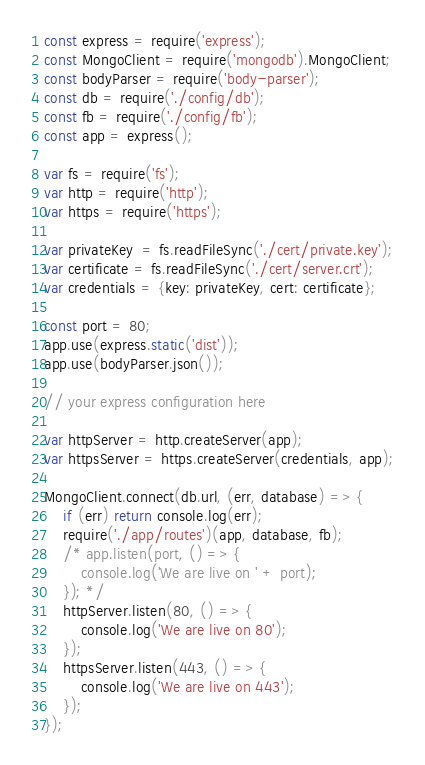Convert code to text. <code><loc_0><loc_0><loc_500><loc_500><_JavaScript_>const express = require('express');
const MongoClient = require('mongodb').MongoClient;
const bodyParser = require('body-parser');
const db = require('./config/db');
const fb = require('./config/fb');
const app = express();

var fs = require('fs');
var http = require('http');
var https = require('https');

var privateKey  = fs.readFileSync('./cert/private.key');
var certificate = fs.readFileSync('./cert/server.crt');
var credentials = {key: privateKey, cert: certificate};

const port = 80;
app.use(express.static('dist'));
app.use(bodyParser.json());

// your express configuration here

var httpServer = http.createServer(app);
var httpsServer = https.createServer(credentials, app);

MongoClient.connect(db.url, (err, database) => {
    if (err) return console.log(err);
    require('./app/routes')(app, database, fb);
    /* app.listen(port, () => {
        console.log('We are live on ' + port);
    }); */
    httpServer.listen(80, () => {
        console.log('We are live on 80');
    });
    httpsServer.listen(443, () => {
        console.log('We are live on 443');
    });
});
</code> 